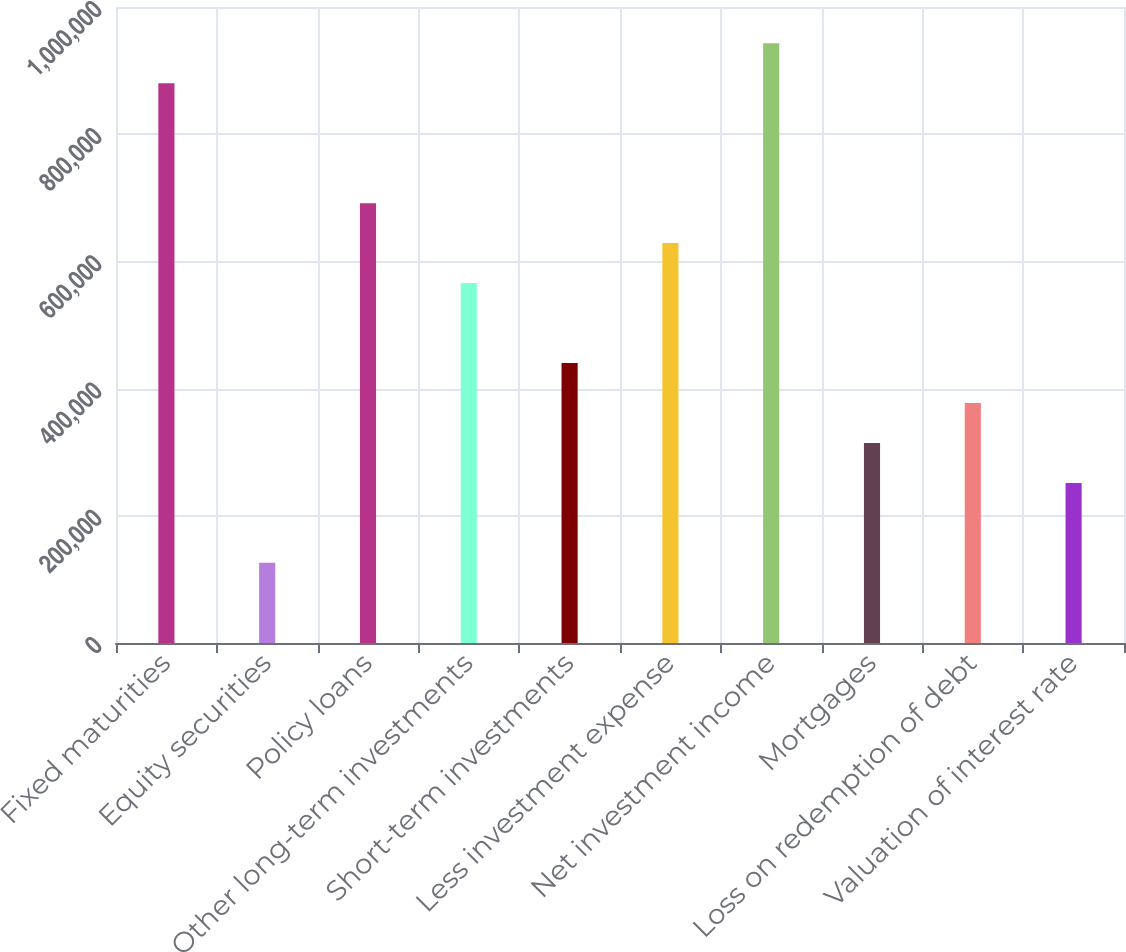<chart> <loc_0><loc_0><loc_500><loc_500><bar_chart><fcel>Fixed maturities<fcel>Equity securities<fcel>Policy loans<fcel>Other long-term investments<fcel>Short-term investments<fcel>Less investment expense<fcel>Net investment income<fcel>Mortgages<fcel>Loss on redemption of debt<fcel>Valuation of interest rate<nl><fcel>880113<fcel>126012<fcel>691588<fcel>565904<fcel>440221<fcel>628746<fcel>942955<fcel>314537<fcel>377379<fcel>251695<nl></chart> 